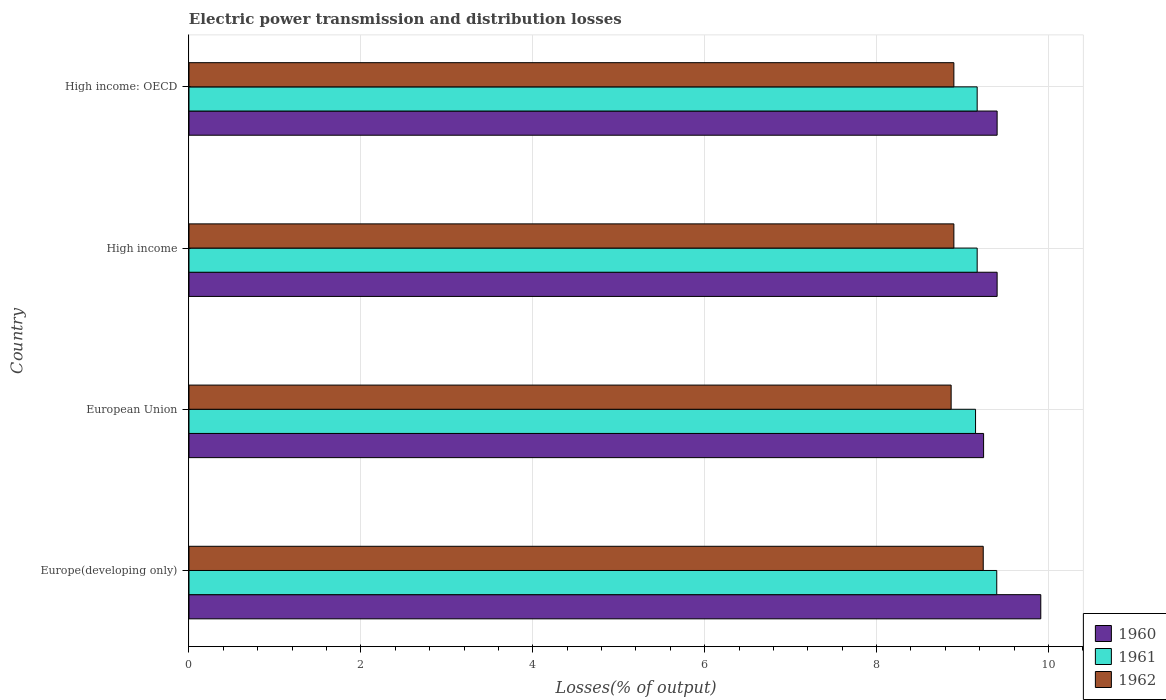How many groups of bars are there?
Your answer should be compact. 4. Are the number of bars per tick equal to the number of legend labels?
Offer a terse response. Yes. How many bars are there on the 1st tick from the top?
Provide a succinct answer. 3. What is the label of the 2nd group of bars from the top?
Ensure brevity in your answer.  High income. In how many cases, is the number of bars for a given country not equal to the number of legend labels?
Your answer should be very brief. 0. What is the electric power transmission and distribution losses in 1961 in European Union?
Your response must be concise. 9.15. Across all countries, what is the maximum electric power transmission and distribution losses in 1962?
Offer a terse response. 9.24. Across all countries, what is the minimum electric power transmission and distribution losses in 1961?
Offer a terse response. 9.15. In which country was the electric power transmission and distribution losses in 1961 maximum?
Offer a very short reply. Europe(developing only). In which country was the electric power transmission and distribution losses in 1960 minimum?
Ensure brevity in your answer.  European Union. What is the total electric power transmission and distribution losses in 1962 in the graph?
Offer a terse response. 35.91. What is the difference between the electric power transmission and distribution losses in 1960 in Europe(developing only) and that in European Union?
Ensure brevity in your answer.  0.67. What is the difference between the electric power transmission and distribution losses in 1961 in Europe(developing only) and the electric power transmission and distribution losses in 1962 in High income?
Your answer should be compact. 0.5. What is the average electric power transmission and distribution losses in 1961 per country?
Give a very brief answer. 9.22. What is the difference between the electric power transmission and distribution losses in 1962 and electric power transmission and distribution losses in 1960 in High income?
Give a very brief answer. -0.5. What is the ratio of the electric power transmission and distribution losses in 1962 in Europe(developing only) to that in High income?
Your answer should be compact. 1.04. What is the difference between the highest and the second highest electric power transmission and distribution losses in 1962?
Give a very brief answer. 0.34. What is the difference between the highest and the lowest electric power transmission and distribution losses in 1962?
Offer a very short reply. 0.37. What is the difference between two consecutive major ticks on the X-axis?
Make the answer very short. 2. Does the graph contain any zero values?
Ensure brevity in your answer.  No. Does the graph contain grids?
Keep it short and to the point. Yes. Where does the legend appear in the graph?
Offer a terse response. Bottom right. How are the legend labels stacked?
Your answer should be very brief. Vertical. What is the title of the graph?
Give a very brief answer. Electric power transmission and distribution losses. Does "1963" appear as one of the legend labels in the graph?
Offer a very short reply. No. What is the label or title of the X-axis?
Offer a terse response. Losses(% of output). What is the Losses(% of output) in 1960 in Europe(developing only)?
Provide a short and direct response. 9.91. What is the Losses(% of output) of 1961 in Europe(developing only)?
Your response must be concise. 9.4. What is the Losses(% of output) of 1962 in Europe(developing only)?
Provide a short and direct response. 9.24. What is the Losses(% of output) in 1960 in European Union?
Your response must be concise. 9.25. What is the Losses(% of output) of 1961 in European Union?
Your answer should be compact. 9.15. What is the Losses(% of output) of 1962 in European Union?
Your answer should be compact. 8.87. What is the Losses(% of output) in 1960 in High income?
Offer a very short reply. 9.4. What is the Losses(% of output) in 1961 in High income?
Offer a terse response. 9.17. What is the Losses(% of output) in 1962 in High income?
Offer a terse response. 8.9. What is the Losses(% of output) in 1960 in High income: OECD?
Your answer should be very brief. 9.4. What is the Losses(% of output) in 1961 in High income: OECD?
Your answer should be very brief. 9.17. What is the Losses(% of output) in 1962 in High income: OECD?
Provide a succinct answer. 8.9. Across all countries, what is the maximum Losses(% of output) of 1960?
Give a very brief answer. 9.91. Across all countries, what is the maximum Losses(% of output) in 1961?
Make the answer very short. 9.4. Across all countries, what is the maximum Losses(% of output) of 1962?
Provide a short and direct response. 9.24. Across all countries, what is the minimum Losses(% of output) of 1960?
Offer a terse response. 9.25. Across all countries, what is the minimum Losses(% of output) of 1961?
Provide a short and direct response. 9.15. Across all countries, what is the minimum Losses(% of output) of 1962?
Provide a short and direct response. 8.87. What is the total Losses(% of output) of 1960 in the graph?
Make the answer very short. 37.96. What is the total Losses(% of output) in 1961 in the graph?
Your response must be concise. 36.89. What is the total Losses(% of output) in 1962 in the graph?
Your response must be concise. 35.91. What is the difference between the Losses(% of output) in 1960 in Europe(developing only) and that in European Union?
Keep it short and to the point. 0.67. What is the difference between the Losses(% of output) of 1961 in Europe(developing only) and that in European Union?
Make the answer very short. 0.25. What is the difference between the Losses(% of output) in 1962 in Europe(developing only) and that in European Union?
Make the answer very short. 0.37. What is the difference between the Losses(% of output) in 1960 in Europe(developing only) and that in High income?
Make the answer very short. 0.51. What is the difference between the Losses(% of output) in 1961 in Europe(developing only) and that in High income?
Offer a terse response. 0.23. What is the difference between the Losses(% of output) of 1962 in Europe(developing only) and that in High income?
Provide a succinct answer. 0.34. What is the difference between the Losses(% of output) of 1960 in Europe(developing only) and that in High income: OECD?
Your answer should be very brief. 0.51. What is the difference between the Losses(% of output) of 1961 in Europe(developing only) and that in High income: OECD?
Provide a short and direct response. 0.23. What is the difference between the Losses(% of output) in 1962 in Europe(developing only) and that in High income: OECD?
Offer a terse response. 0.34. What is the difference between the Losses(% of output) of 1960 in European Union and that in High income?
Offer a very short reply. -0.16. What is the difference between the Losses(% of output) in 1961 in European Union and that in High income?
Provide a short and direct response. -0.02. What is the difference between the Losses(% of output) in 1962 in European Union and that in High income?
Your answer should be compact. -0.03. What is the difference between the Losses(% of output) of 1960 in European Union and that in High income: OECD?
Your response must be concise. -0.16. What is the difference between the Losses(% of output) of 1961 in European Union and that in High income: OECD?
Your answer should be compact. -0.02. What is the difference between the Losses(% of output) in 1962 in European Union and that in High income: OECD?
Provide a succinct answer. -0.03. What is the difference between the Losses(% of output) in 1960 in Europe(developing only) and the Losses(% of output) in 1961 in European Union?
Ensure brevity in your answer.  0.76. What is the difference between the Losses(% of output) of 1960 in Europe(developing only) and the Losses(% of output) of 1962 in European Union?
Provide a succinct answer. 1.04. What is the difference between the Losses(% of output) in 1961 in Europe(developing only) and the Losses(% of output) in 1962 in European Union?
Your answer should be very brief. 0.53. What is the difference between the Losses(% of output) of 1960 in Europe(developing only) and the Losses(% of output) of 1961 in High income?
Give a very brief answer. 0.74. What is the difference between the Losses(% of output) in 1960 in Europe(developing only) and the Losses(% of output) in 1962 in High income?
Keep it short and to the point. 1.01. What is the difference between the Losses(% of output) of 1961 in Europe(developing only) and the Losses(% of output) of 1962 in High income?
Provide a short and direct response. 0.5. What is the difference between the Losses(% of output) of 1960 in Europe(developing only) and the Losses(% of output) of 1961 in High income: OECD?
Provide a short and direct response. 0.74. What is the difference between the Losses(% of output) in 1960 in Europe(developing only) and the Losses(% of output) in 1962 in High income: OECD?
Provide a succinct answer. 1.01. What is the difference between the Losses(% of output) of 1961 in Europe(developing only) and the Losses(% of output) of 1962 in High income: OECD?
Give a very brief answer. 0.5. What is the difference between the Losses(% of output) of 1960 in European Union and the Losses(% of output) of 1961 in High income?
Make the answer very short. 0.07. What is the difference between the Losses(% of output) in 1960 in European Union and the Losses(% of output) in 1962 in High income?
Make the answer very short. 0.35. What is the difference between the Losses(% of output) in 1961 in European Union and the Losses(% of output) in 1962 in High income?
Offer a very short reply. 0.25. What is the difference between the Losses(% of output) in 1960 in European Union and the Losses(% of output) in 1961 in High income: OECD?
Provide a succinct answer. 0.07. What is the difference between the Losses(% of output) of 1960 in European Union and the Losses(% of output) of 1962 in High income: OECD?
Your answer should be compact. 0.35. What is the difference between the Losses(% of output) in 1961 in European Union and the Losses(% of output) in 1962 in High income: OECD?
Make the answer very short. 0.25. What is the difference between the Losses(% of output) of 1960 in High income and the Losses(% of output) of 1961 in High income: OECD?
Offer a very short reply. 0.23. What is the difference between the Losses(% of output) in 1960 in High income and the Losses(% of output) in 1962 in High income: OECD?
Your answer should be compact. 0.5. What is the difference between the Losses(% of output) of 1961 in High income and the Losses(% of output) of 1962 in High income: OECD?
Provide a succinct answer. 0.27. What is the average Losses(% of output) in 1960 per country?
Keep it short and to the point. 9.49. What is the average Losses(% of output) in 1961 per country?
Your answer should be compact. 9.22. What is the average Losses(% of output) of 1962 per country?
Your response must be concise. 8.98. What is the difference between the Losses(% of output) of 1960 and Losses(% of output) of 1961 in Europe(developing only)?
Your answer should be compact. 0.51. What is the difference between the Losses(% of output) in 1960 and Losses(% of output) in 1962 in Europe(developing only)?
Give a very brief answer. 0.67. What is the difference between the Losses(% of output) in 1961 and Losses(% of output) in 1962 in Europe(developing only)?
Offer a very short reply. 0.16. What is the difference between the Losses(% of output) in 1960 and Losses(% of output) in 1961 in European Union?
Keep it short and to the point. 0.09. What is the difference between the Losses(% of output) in 1960 and Losses(% of output) in 1962 in European Union?
Your answer should be compact. 0.38. What is the difference between the Losses(% of output) in 1961 and Losses(% of output) in 1962 in European Union?
Provide a succinct answer. 0.28. What is the difference between the Losses(% of output) in 1960 and Losses(% of output) in 1961 in High income?
Offer a terse response. 0.23. What is the difference between the Losses(% of output) in 1960 and Losses(% of output) in 1962 in High income?
Your response must be concise. 0.5. What is the difference between the Losses(% of output) in 1961 and Losses(% of output) in 1962 in High income?
Provide a short and direct response. 0.27. What is the difference between the Losses(% of output) in 1960 and Losses(% of output) in 1961 in High income: OECD?
Keep it short and to the point. 0.23. What is the difference between the Losses(% of output) in 1960 and Losses(% of output) in 1962 in High income: OECD?
Your answer should be very brief. 0.5. What is the difference between the Losses(% of output) of 1961 and Losses(% of output) of 1962 in High income: OECD?
Provide a short and direct response. 0.27. What is the ratio of the Losses(% of output) of 1960 in Europe(developing only) to that in European Union?
Give a very brief answer. 1.07. What is the ratio of the Losses(% of output) of 1961 in Europe(developing only) to that in European Union?
Your answer should be compact. 1.03. What is the ratio of the Losses(% of output) in 1962 in Europe(developing only) to that in European Union?
Offer a terse response. 1.04. What is the ratio of the Losses(% of output) of 1960 in Europe(developing only) to that in High income?
Your response must be concise. 1.05. What is the ratio of the Losses(% of output) of 1961 in Europe(developing only) to that in High income?
Your answer should be compact. 1.02. What is the ratio of the Losses(% of output) of 1962 in Europe(developing only) to that in High income?
Offer a terse response. 1.04. What is the ratio of the Losses(% of output) in 1960 in Europe(developing only) to that in High income: OECD?
Provide a succinct answer. 1.05. What is the ratio of the Losses(% of output) of 1961 in Europe(developing only) to that in High income: OECD?
Your answer should be very brief. 1.02. What is the ratio of the Losses(% of output) in 1962 in Europe(developing only) to that in High income: OECD?
Keep it short and to the point. 1.04. What is the ratio of the Losses(% of output) of 1960 in European Union to that in High income?
Ensure brevity in your answer.  0.98. What is the ratio of the Losses(% of output) in 1961 in European Union to that in High income?
Offer a very short reply. 1. What is the ratio of the Losses(% of output) in 1960 in European Union to that in High income: OECD?
Your response must be concise. 0.98. What is the ratio of the Losses(% of output) in 1961 in European Union to that in High income: OECD?
Keep it short and to the point. 1. What is the ratio of the Losses(% of output) of 1962 in European Union to that in High income: OECD?
Offer a terse response. 1. What is the ratio of the Losses(% of output) of 1960 in High income to that in High income: OECD?
Offer a terse response. 1. What is the ratio of the Losses(% of output) in 1962 in High income to that in High income: OECD?
Your answer should be compact. 1. What is the difference between the highest and the second highest Losses(% of output) of 1960?
Give a very brief answer. 0.51. What is the difference between the highest and the second highest Losses(% of output) in 1961?
Offer a terse response. 0.23. What is the difference between the highest and the second highest Losses(% of output) of 1962?
Provide a succinct answer. 0.34. What is the difference between the highest and the lowest Losses(% of output) of 1960?
Give a very brief answer. 0.67. What is the difference between the highest and the lowest Losses(% of output) of 1961?
Your response must be concise. 0.25. What is the difference between the highest and the lowest Losses(% of output) in 1962?
Keep it short and to the point. 0.37. 